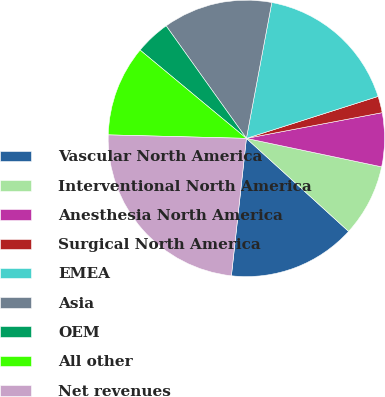Convert chart to OTSL. <chart><loc_0><loc_0><loc_500><loc_500><pie_chart><fcel>Vascular North America<fcel>Interventional North America<fcel>Anesthesia North America<fcel>Surgical North America<fcel>EMEA<fcel>Asia<fcel>OEM<fcel>All other<fcel>Net revenues<nl><fcel>14.98%<fcel>8.45%<fcel>6.28%<fcel>1.93%<fcel>17.15%<fcel>12.8%<fcel>4.11%<fcel>10.63%<fcel>23.67%<nl></chart> 